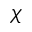<formula> <loc_0><loc_0><loc_500><loc_500>\chi</formula> 